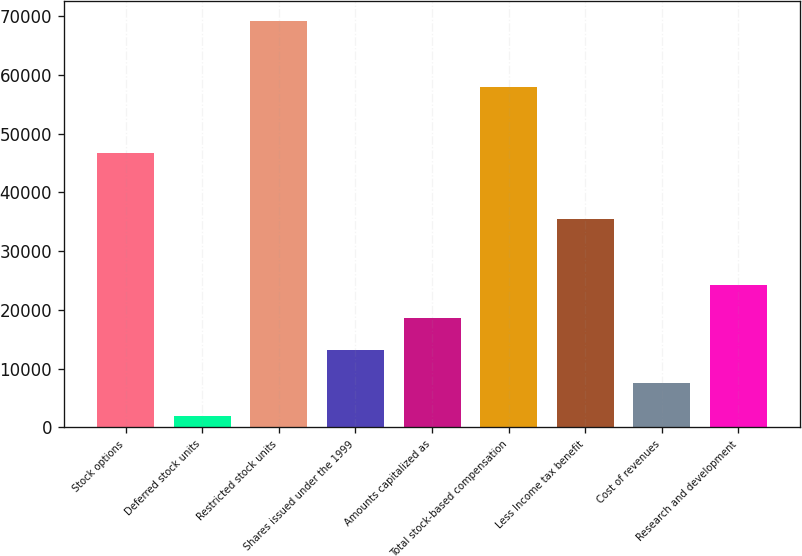Convert chart to OTSL. <chart><loc_0><loc_0><loc_500><loc_500><bar_chart><fcel>Stock options<fcel>Deferred stock units<fcel>Restricted stock units<fcel>Shares issued under the 1999<fcel>Amounts capitalized as<fcel>Total stock-based compensation<fcel>Less Income tax benefit<fcel>Cost of revenues<fcel>Research and development<nl><fcel>46696.2<fcel>1885<fcel>69101.8<fcel>13087.8<fcel>18689.2<fcel>57899<fcel>35493.4<fcel>7486.4<fcel>24290.6<nl></chart> 